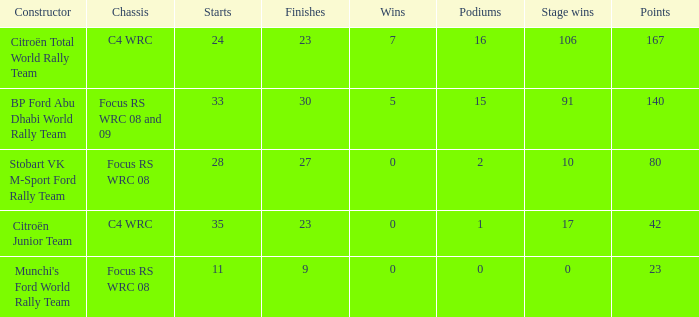What is the total number of points when the constructor is citroën total world rally team and the wins is less than 7? 0.0. 